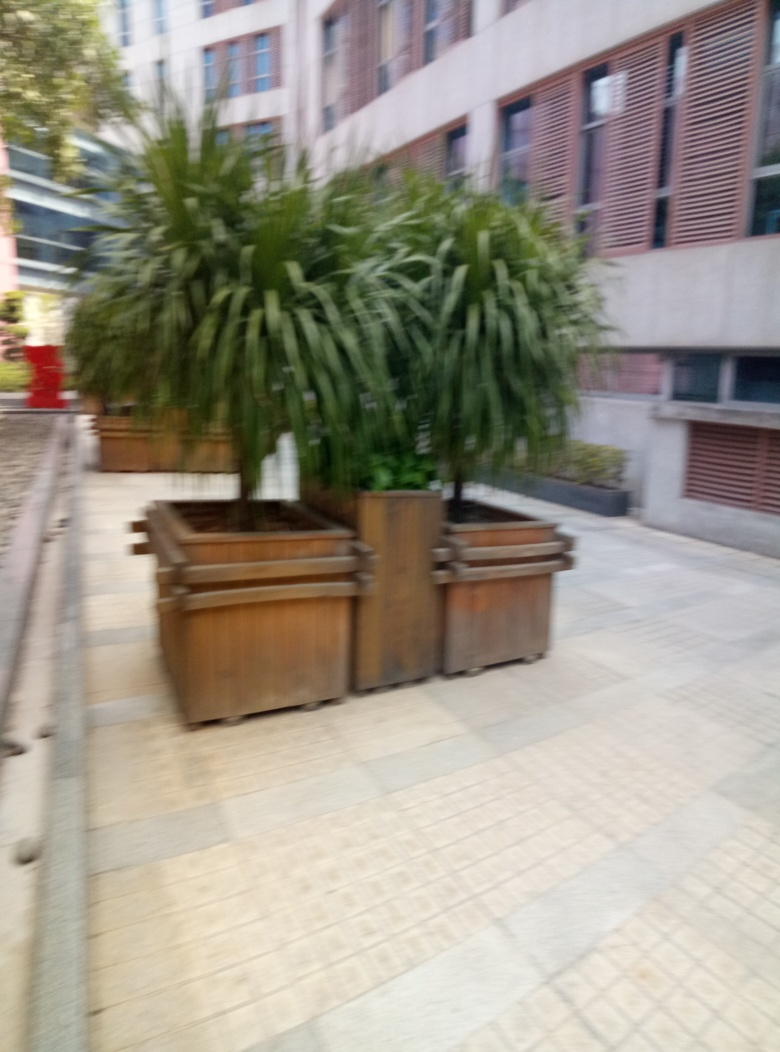How would you describe the clarity of the image?
A. Crystal clear
B. Significantly blurred
C. Slightly blurry
D. Perfectly sharp
Answer with the option's letter from the given choices directly.
 B. 